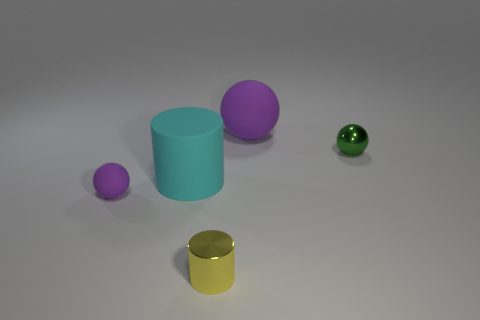Is the number of large purple rubber spheres left of the small yellow cylinder less than the number of large rubber balls that are on the left side of the cyan rubber object?
Your response must be concise. No. The other matte thing that is the same color as the tiny rubber thing is what size?
Ensure brevity in your answer.  Large. How many purple objects are left of the small object that is in front of the ball that is in front of the tiny green object?
Your response must be concise. 1. Is the color of the small metal sphere the same as the large sphere?
Give a very brief answer. No. Is there a large cylinder that has the same color as the metal sphere?
Offer a very short reply. No. What color is the cylinder that is the same size as the metal ball?
Provide a succinct answer. Yellow. Are there any cyan rubber things of the same shape as the yellow metal object?
Provide a succinct answer. Yes. The matte thing that is the same color as the small rubber ball is what shape?
Offer a terse response. Sphere. There is a purple sphere left of the yellow cylinder left of the green metal object; is there a big purple thing on the left side of it?
Your response must be concise. No. There is a purple thing that is the same size as the cyan rubber cylinder; what shape is it?
Offer a very short reply. Sphere. 